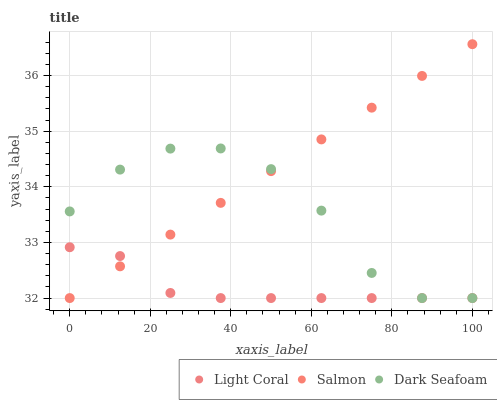Does Light Coral have the minimum area under the curve?
Answer yes or no. Yes. Does Salmon have the maximum area under the curve?
Answer yes or no. Yes. Does Dark Seafoam have the minimum area under the curve?
Answer yes or no. No. Does Dark Seafoam have the maximum area under the curve?
Answer yes or no. No. Is Salmon the smoothest?
Answer yes or no. Yes. Is Dark Seafoam the roughest?
Answer yes or no. Yes. Is Dark Seafoam the smoothest?
Answer yes or no. No. Is Salmon the roughest?
Answer yes or no. No. Does Light Coral have the lowest value?
Answer yes or no. Yes. Does Salmon have the highest value?
Answer yes or no. Yes. Does Dark Seafoam have the highest value?
Answer yes or no. No. Does Dark Seafoam intersect Salmon?
Answer yes or no. Yes. Is Dark Seafoam less than Salmon?
Answer yes or no. No. Is Dark Seafoam greater than Salmon?
Answer yes or no. No. 